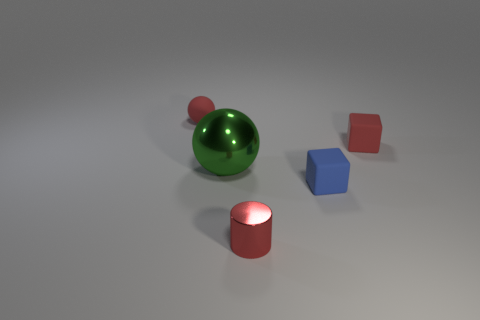Add 3 small cyan rubber cylinders. How many objects exist? 8 Subtract all cubes. How many objects are left? 3 Subtract all large green things. Subtract all red blocks. How many objects are left? 3 Add 5 large green spheres. How many large green spheres are left? 6 Add 4 big yellow metallic spheres. How many big yellow metallic spheres exist? 4 Subtract 1 red cylinders. How many objects are left? 4 Subtract 2 blocks. How many blocks are left? 0 Subtract all red blocks. Subtract all cyan cylinders. How many blocks are left? 1 Subtract all gray balls. How many yellow cylinders are left? 0 